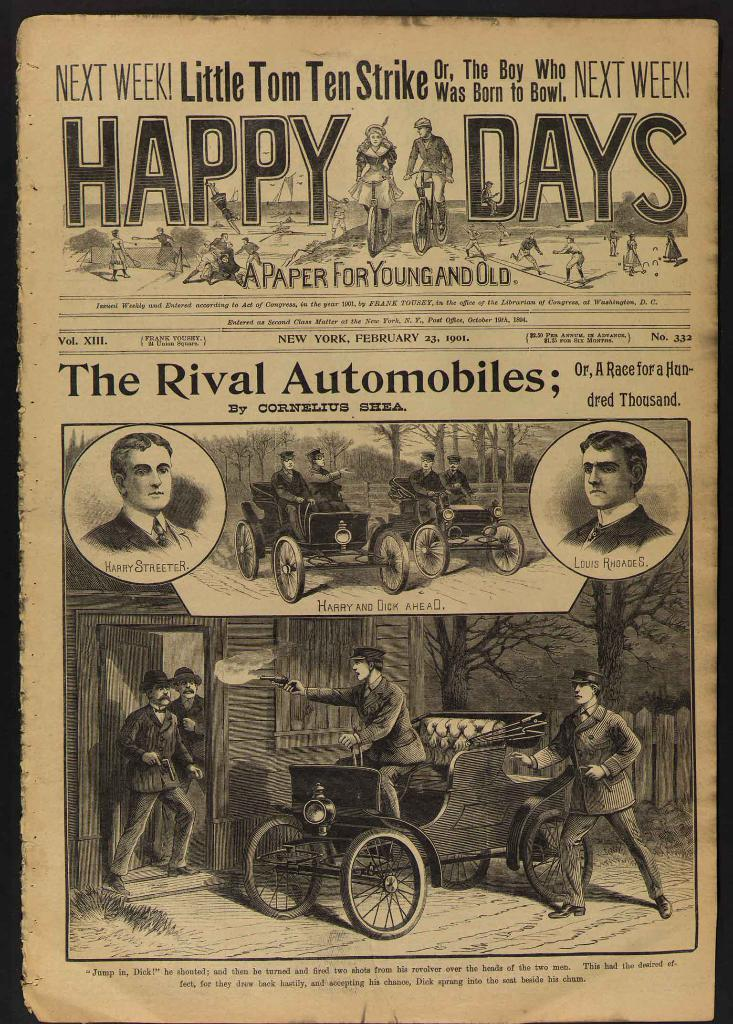What is the main subject of the poster in the image? The poster contains photos of vehicles and people. What else can be found on the poster besides the images? There is text written on the poster. Where is the rabbit hiding in the image? There is no rabbit present in the image. What type of rock is featured in the image? There is no rock present in the image. 